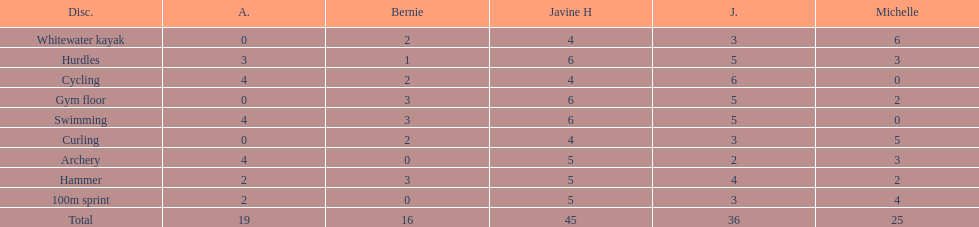Mention a girl who obtained the same points in bicycling and arrow shooting. Amanda. 